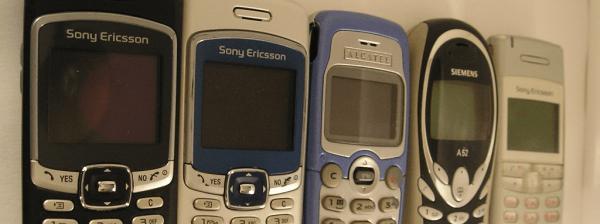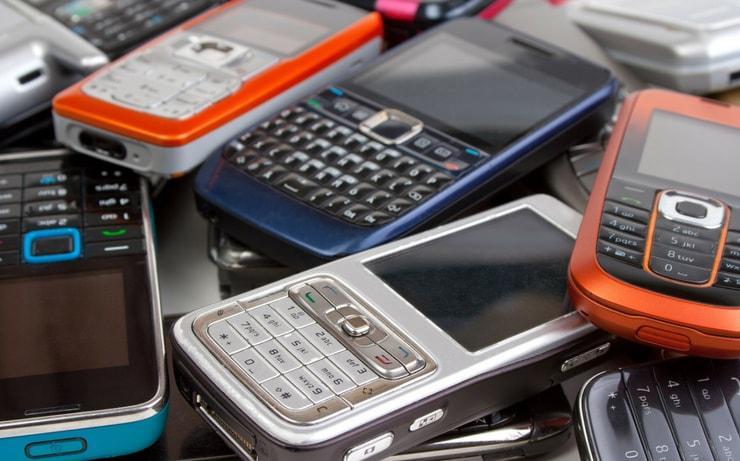The first image is the image on the left, the second image is the image on the right. Assess this claim about the two images: "The right image contains a stack of four phones, with the phones stacked in a staggered fashion instead of aligned.". Correct or not? Answer yes or no. No. The first image is the image on the left, the second image is the image on the right. Considering the images on both sides, is "At least four phones are stacked on top of each other in at least one of the pictures." valid? Answer yes or no. No. 